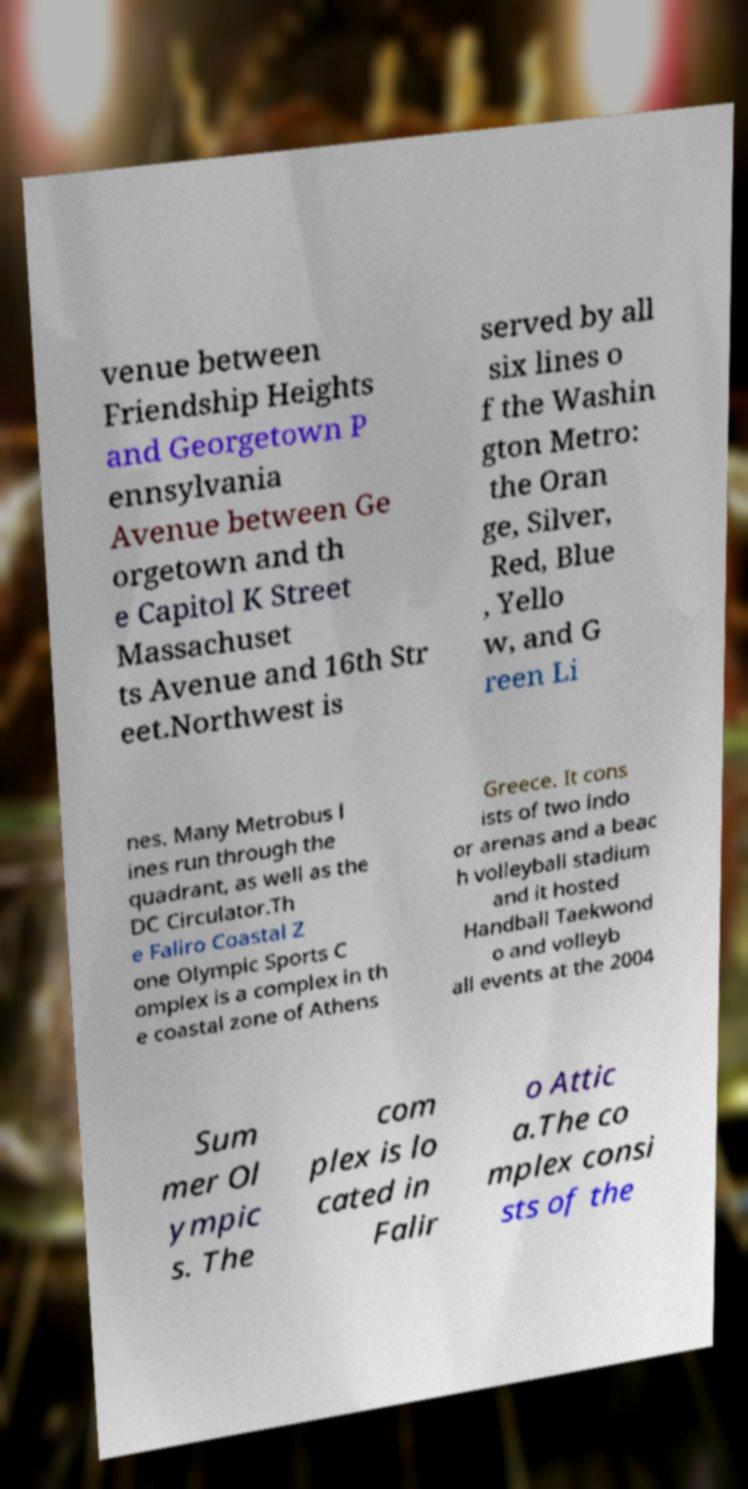Please identify and transcribe the text found in this image. venue between Friendship Heights and Georgetown P ennsylvania Avenue between Ge orgetown and th e Capitol K Street Massachuset ts Avenue and 16th Str eet.Northwest is served by all six lines o f the Washin gton Metro: the Oran ge, Silver, Red, Blue , Yello w, and G reen Li nes. Many Metrobus l ines run through the quadrant, as well as the DC Circulator.Th e Faliro Coastal Z one Olympic Sports C omplex is a complex in th e coastal zone of Athens Greece. It cons ists of two indo or arenas and a beac h volleyball stadium and it hosted Handball Taekwond o and volleyb all events at the 2004 Sum mer Ol ympic s. The com plex is lo cated in Falir o Attic a.The co mplex consi sts of the 